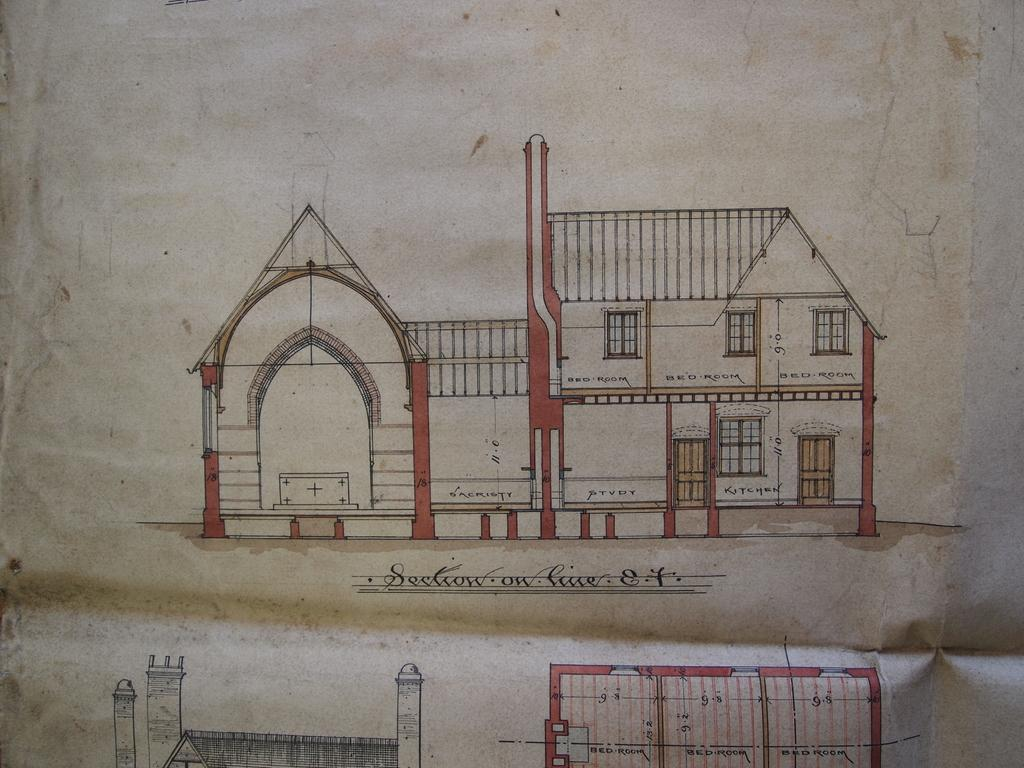What is depicted on the piece of paper in the image? There is a blueprint of buildings in the image. What material is the blueprint printed on? The blueprint is on a piece of paper. How many cakes are shown in the blueprint? There are no cakes depicted in the blueprint; it shows buildings. 